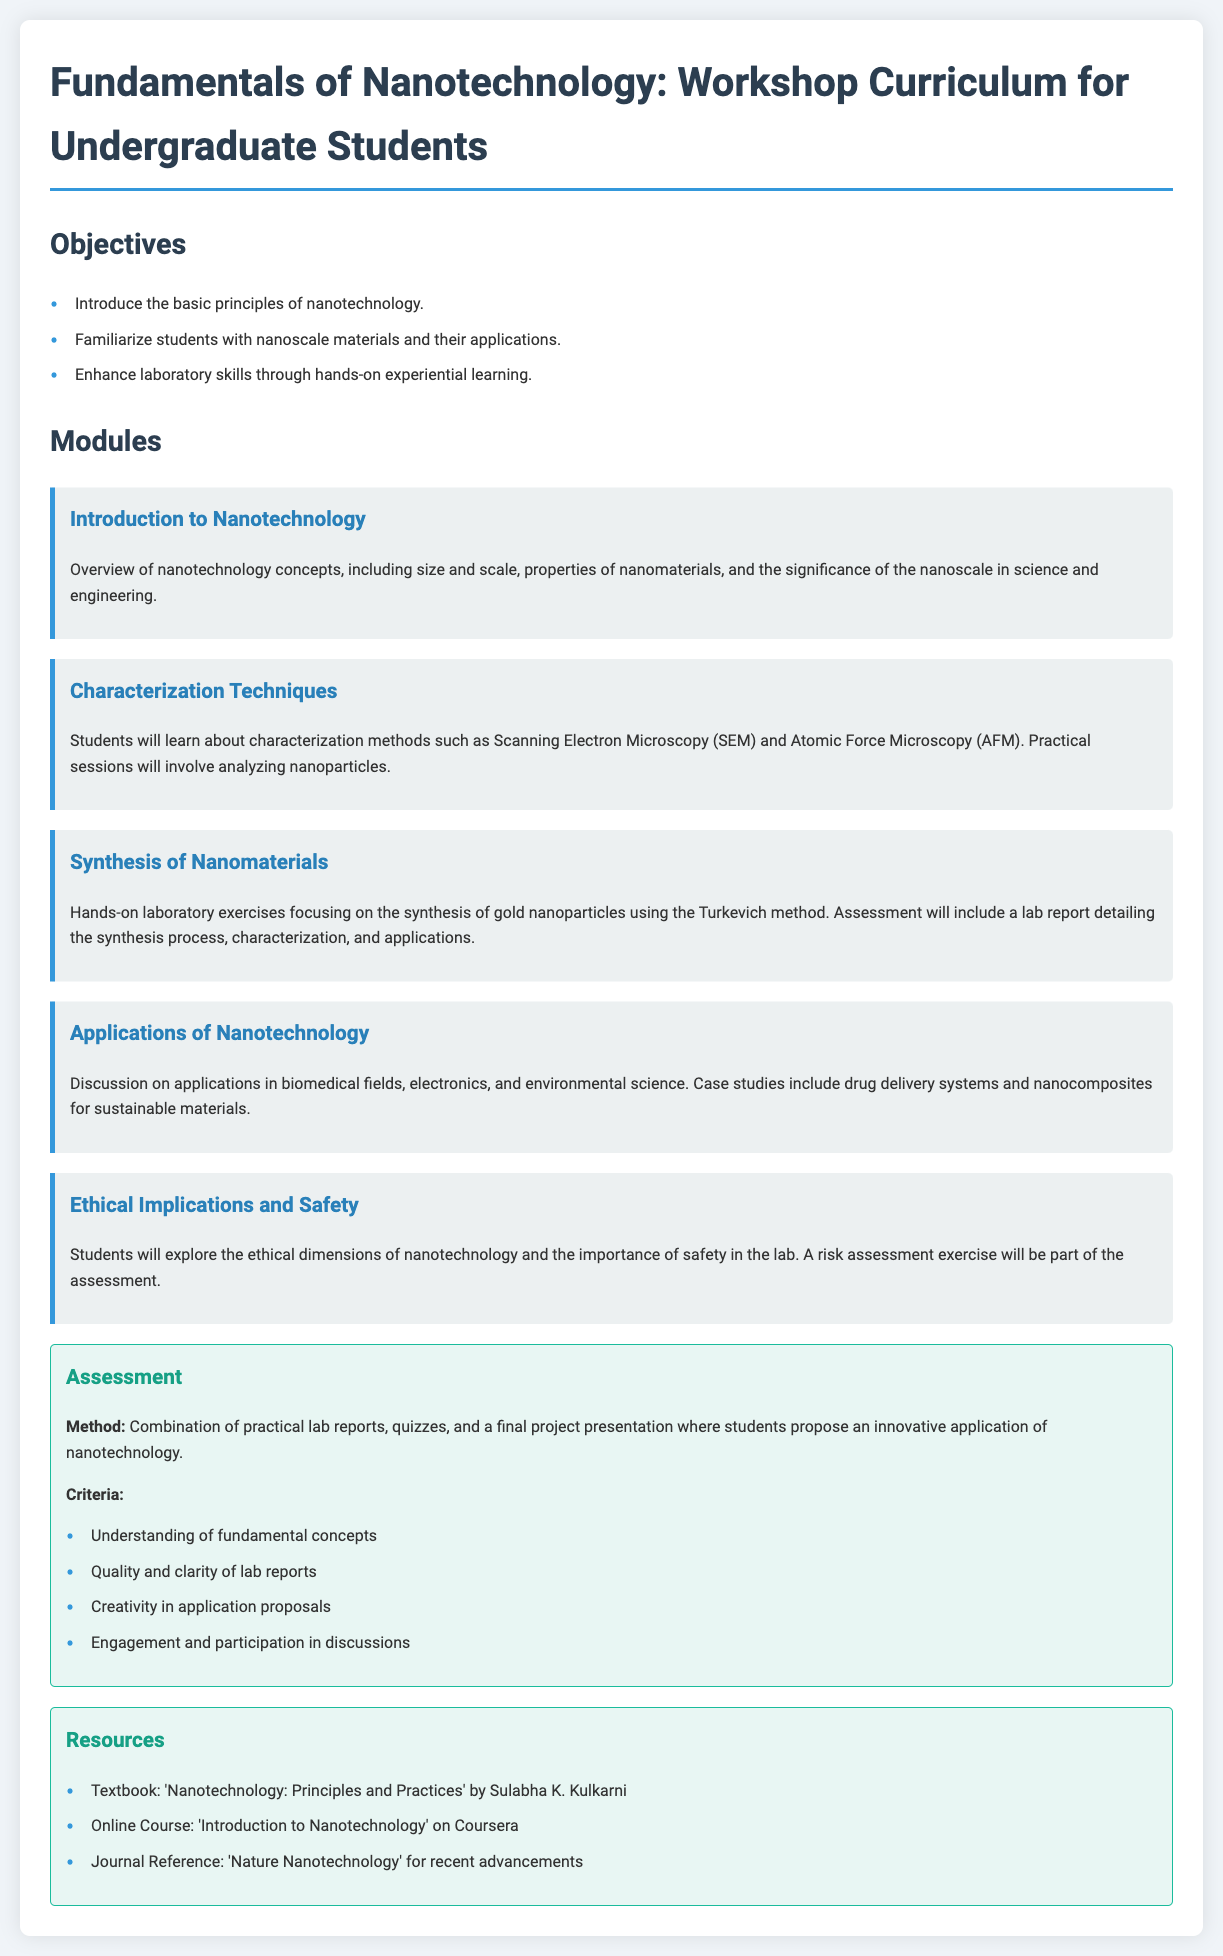What is the title of the document? The title of the document can be found at the top of the rendered page, which states the workshop curriculum theme.
Answer: Fundamentals of Nanotechnology: Workshop Curriculum for Undergraduate Students What is one of the objectives of the workshop? One of the objectives is listed in the section detailing the goals of the workshop and outlines what students will learn.
Answer: Introduce the basic principles of nanotechnology Which characterization technique is mentioned in the curriculum? The curriculum details specific characterization techniques that students will learn about in one of the modules.
Answer: Scanning Electron Microscopy (SEM) What hands-on exercise is included in the synthesis module? The document provides details about practical lab exercises within the synthesis module where specific procedures are performed.
Answer: Synthesis of gold nanoparticles using the Turkevich method What is included in the assessment criteria? The assessment section outlines specific aspects that will be evaluated for student reports and presentations, which indicates the expected standards.
Answer: Understanding of fundamental concepts What resource is recommended for further reading? The resources section of the document lists suggested materials for students to explore beyond the workshop curriculum for better insights.
Answer: Textbook: 'Nanotechnology: Principles and Practices' by Sulabha K. Kulkarni How many modules are listed in the curriculum? By counting the distinct modules detailed in the curriculum section, one can determine the total number of subjects covered.
Answer: Five What type of assessment is mentioned for the course? The document specifies the method of evaluation in the assessment section, detailing how student learning will be measured.
Answer: Combination of practical lab reports, quizzes, and a final project presentation What important ethical dimension is discussed in the workshop? The workshop addresses various important topics, including ethical issues related to the subject matter being taught.
Answer: Ethical Implications and Safety 